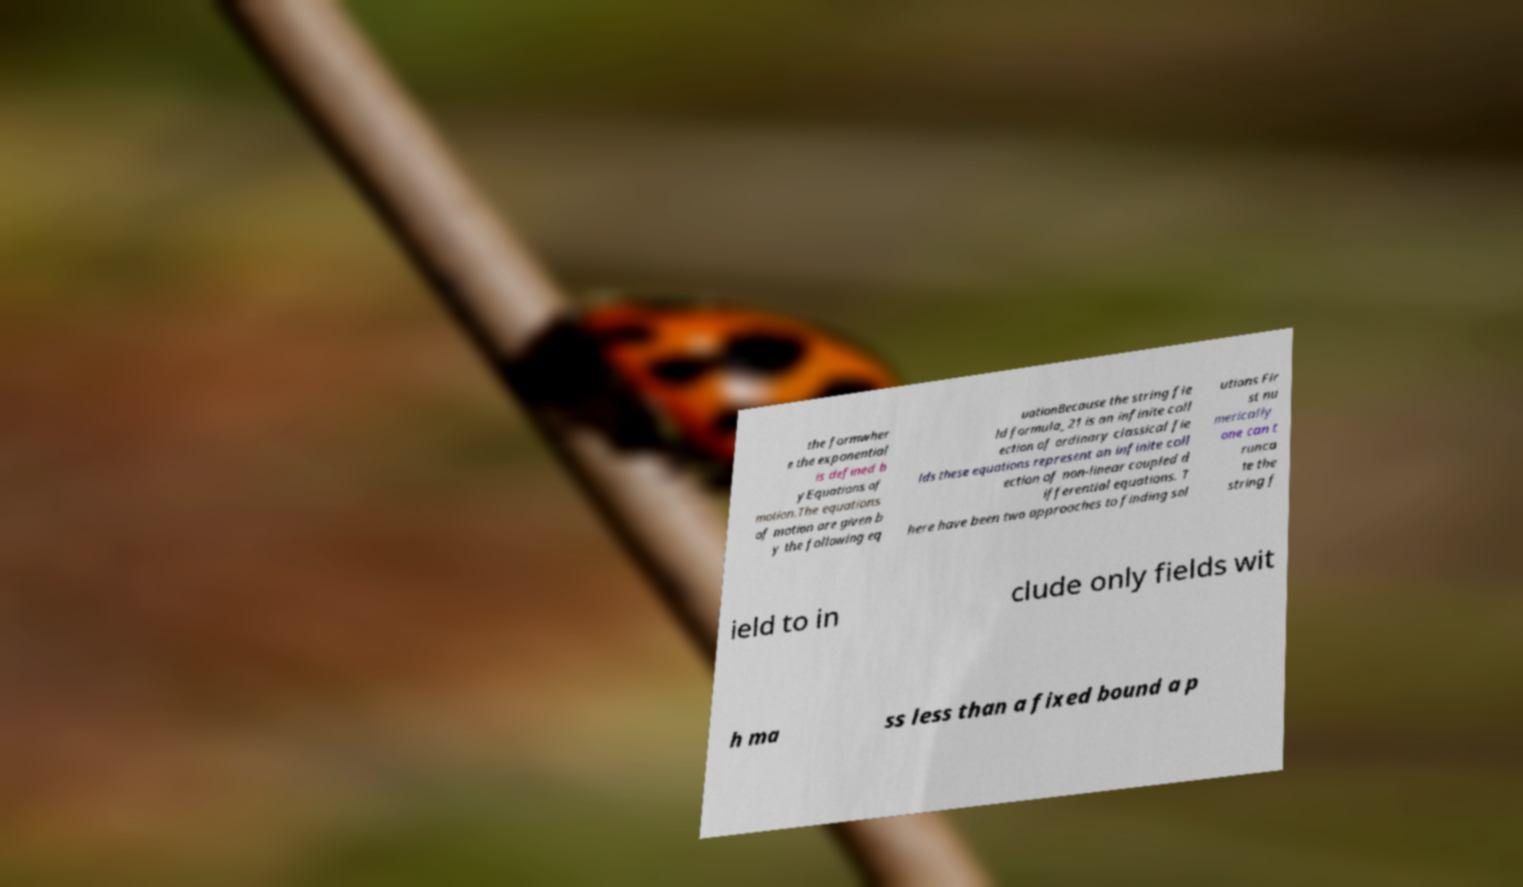I need the written content from this picture converted into text. Can you do that? the formwher e the exponential is defined b yEquations of motion.The equations of motion are given b y the following eq uationBecause the string fie ld formula_21 is an infinite coll ection of ordinary classical fie lds these equations represent an infinite coll ection of non-linear coupled d ifferential equations. T here have been two approaches to finding sol utions Fir st nu merically one can t runca te the string f ield to in clude only fields wit h ma ss less than a fixed bound a p 